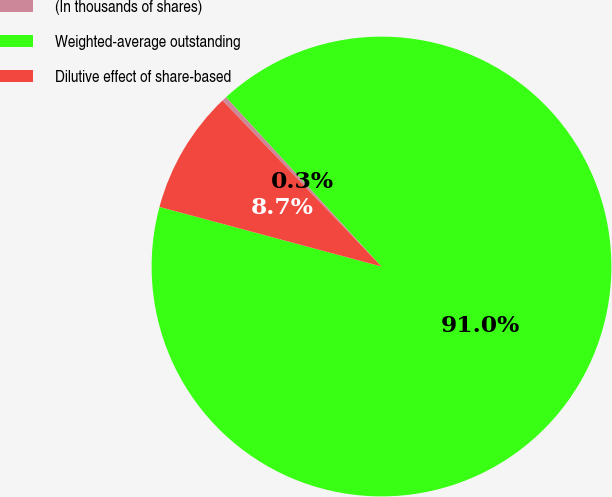<chart> <loc_0><loc_0><loc_500><loc_500><pie_chart><fcel>(In thousands of shares)<fcel>Weighted-average outstanding<fcel>Dilutive effect of share-based<nl><fcel>0.34%<fcel>90.99%<fcel>8.67%<nl></chart> 